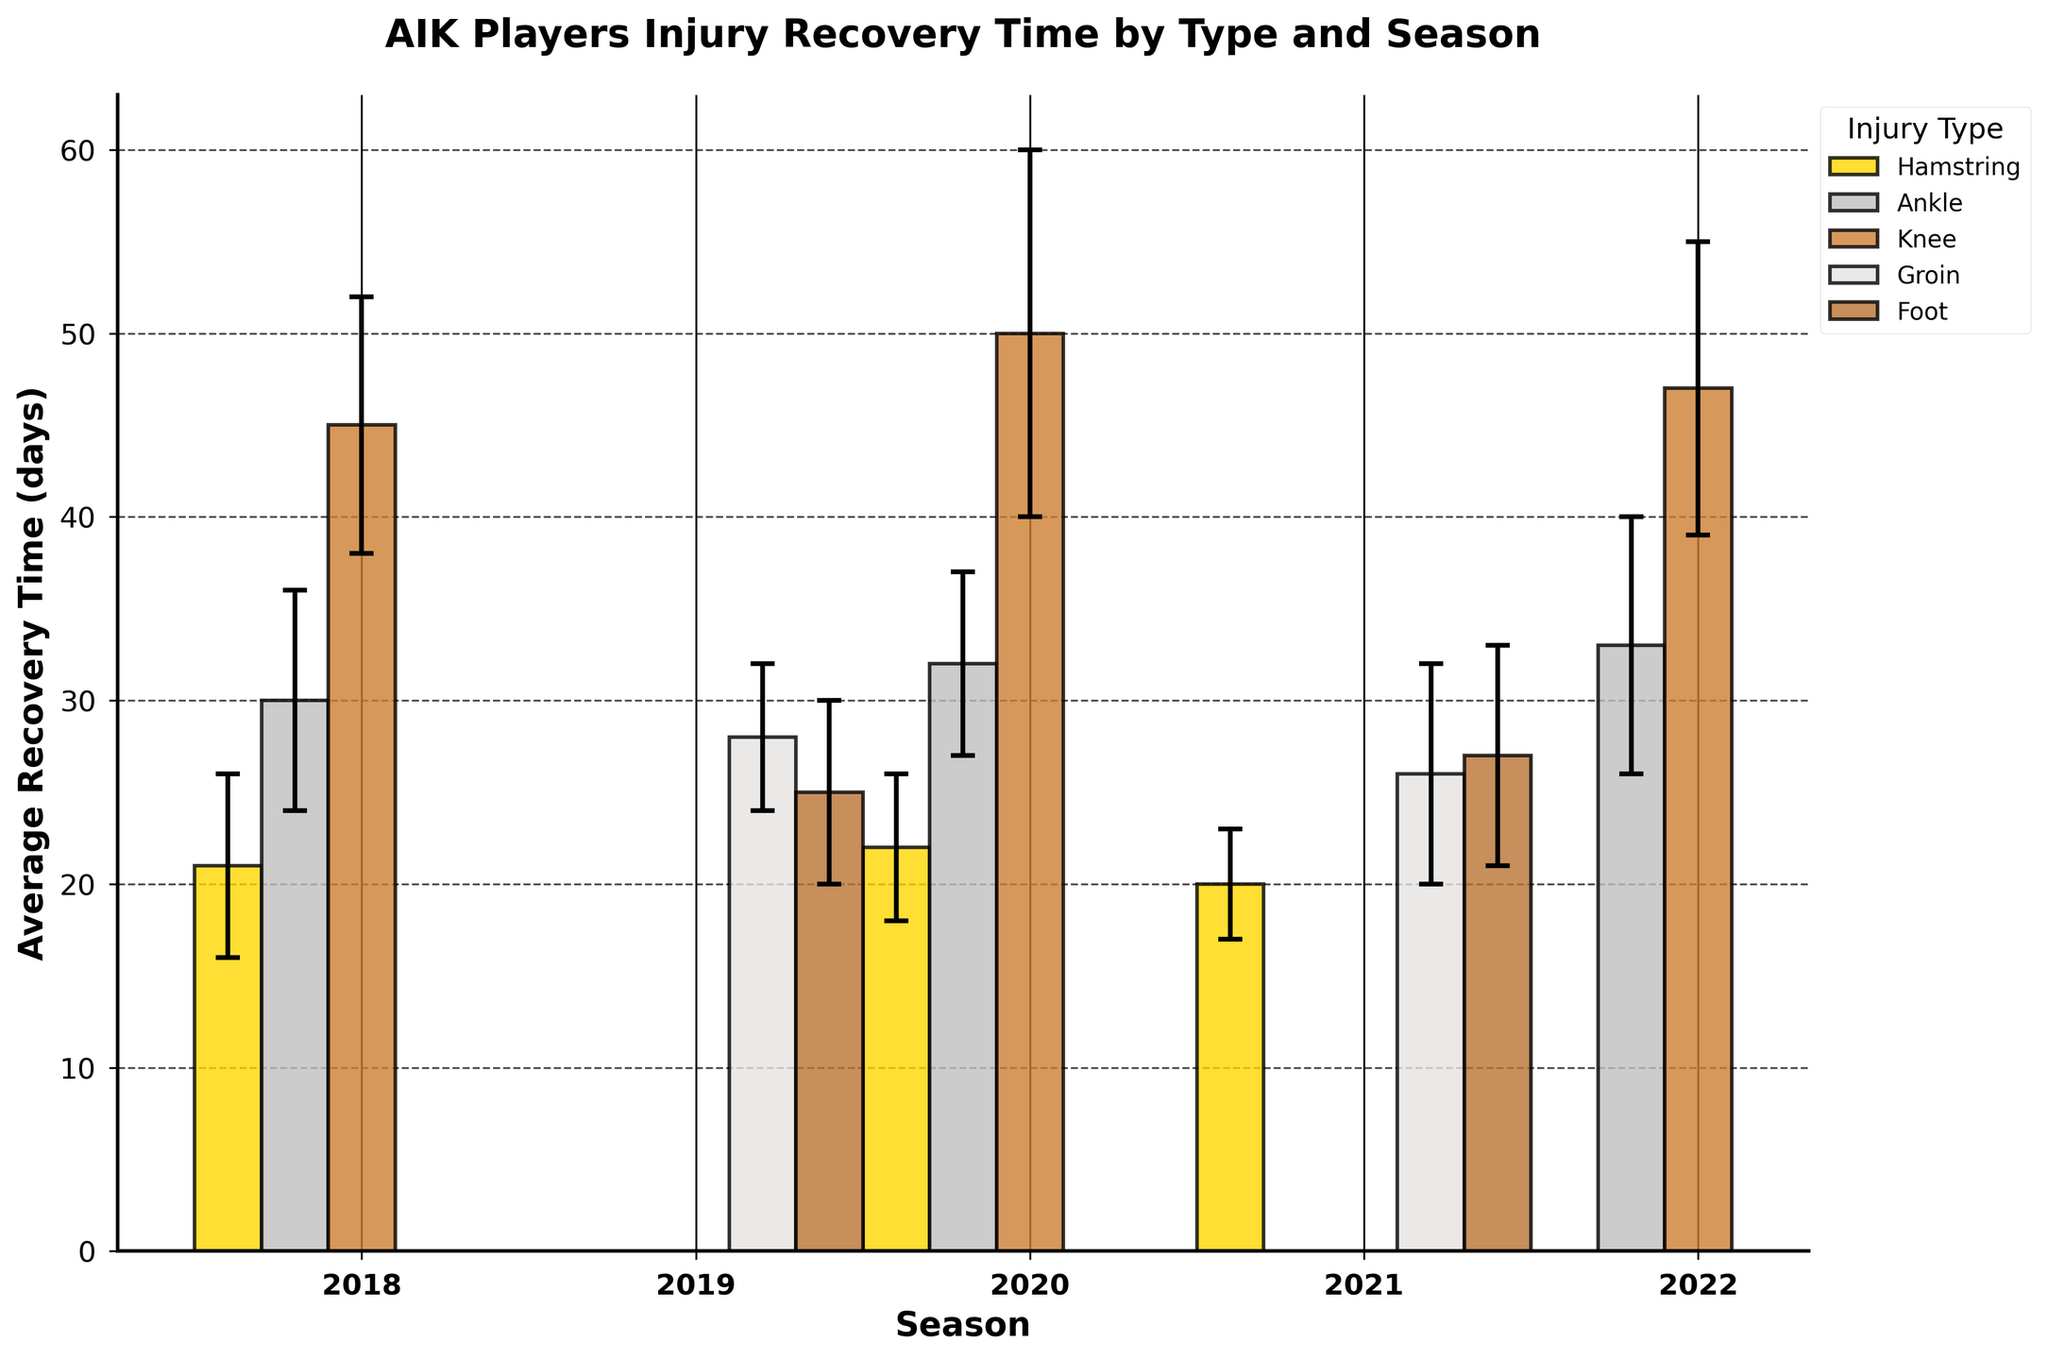How many different injury types are displayed in the figure? By visually inspecting the figure's legend, we can count the number of distinct injury types listed.
Answer: 5 What's the total number of seasons depicted in the figure? Look at the x-axis labels and count the number of different seasons shown.
Answer: 5 Which season has the highest average recovery time for knee injuries? Locate the knee group bars for each season and compare their heights to find the highest one.
Answer: 2022 How does the average recovery time for ankle injuries compare between 2018 and 2022? Identify the ankle injury bars for 2018 and 2022, then compare their heights to see which one is taller.
Answer: Higher in 2022 Which injury type has the lowest average recovery time in 2021? Find the 2021 bars and compare their heights, then identify the one with the shortest bar.
Answer: Hamstring What's the average recovery time for hamstring injuries across all seasons? Sum the average recovery times for hamstring injuries across all seasons and divide by the number of seasons. (21 + 22 + 20) / 3 = 63/3.
Answer: 21 days Which injury type has the largest standard deviation in average recovery time for 2020? Look at the error bars (caps) for 2020 and identify the injury type with the longest error bars.
Answer: Knee Compare the average recovery times for groin injuries in 2019 and 2021. By how many days do they differ? Identify the groin injury bars for 2019 and 2021, and subtract the shorter bar's height from the taller bar's height (26 - 28).
Answer: 2 days How consistent are recovery times for foot injuries across the seasons in terms of standard deviation? Analyze the error bars for foot injury recovery times across seasons and see if they appear similar or vary widely.
Answer: Consistent Determine the average recovery time for knee injuries in 2020 based on the error bar given. How far can the lower bound drop in days? Subtract the standard deviation from the average recovery time for knee injuries in 2020 (50 - 10).
Answer: 40 days 